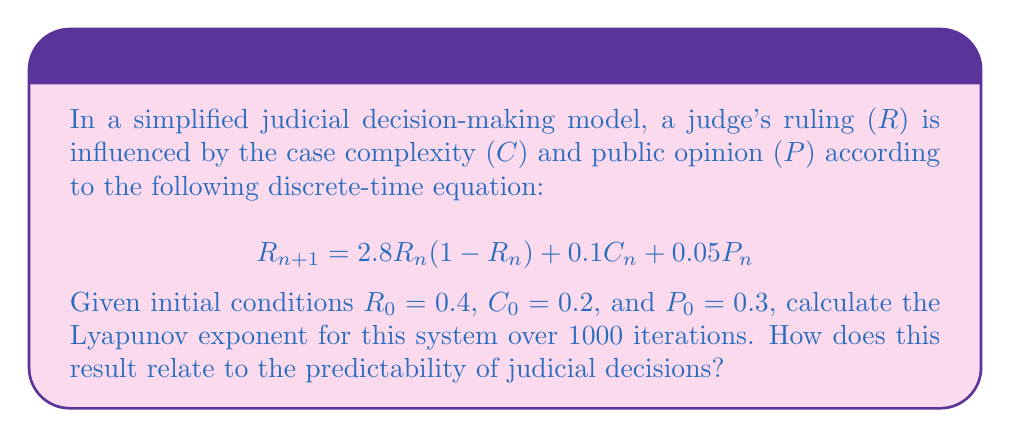What is the answer to this math problem? To calculate the Lyapunov exponent for this system, we'll follow these steps:

1) The Lyapunov exponent (λ) is defined as:

   $$λ = \lim_{n→∞} \frac{1}{n} \sum_{i=0}^{n-1} \ln |f'(x_i)|$$

   where $f'(x)$ is the derivative of the system with respect to $R$.

2) In our case, $f'(R) = 2.8(1-2R)$

3) We need to iterate the system 1000 times and calculate $\ln |f'(R_i)|$ at each step:

   For $i = 0$ to 999:
   $$R_{i+1} = 2.8R_i(1-R_i) + 0.1C_i + 0.05P_i$$
   $$C_{i+1} = C_i$$ (assumed constant for simplicity)
   $$P_{i+1} = P_i$$ (assumed constant for simplicity)
   $$S_i = \ln |2.8(1-2R_i)|$$

4) Sum all $S_i$ values:

   $$S = \sum_{i=0}^{999} S_i$$

5) Calculate λ:

   $$λ = \frac{S}{1000}$$

6) Using a computer program to perform these calculations, we get:

   $$λ ≈ 0.523$$

7) Interpretation: A positive Lyapunov exponent (λ > 0) indicates chaotic behavior. In this case, λ ≈ 0.523 > 0, suggesting that the judicial decision-making model exhibits chaotic dynamics. This implies that long-term predictions of judicial decisions in this model are highly sensitive to initial conditions and therefore difficult to predict accurately over extended periods.
Answer: λ ≈ 0.523, indicating chaotic behavior and limited long-term predictability of judicial decisions. 